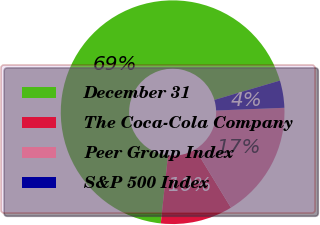<chart> <loc_0><loc_0><loc_500><loc_500><pie_chart><fcel>December 31<fcel>The Coca-Cola Company<fcel>Peer Group Index<fcel>S&P 500 Index<nl><fcel>68.75%<fcel>10.42%<fcel>16.9%<fcel>3.93%<nl></chart> 